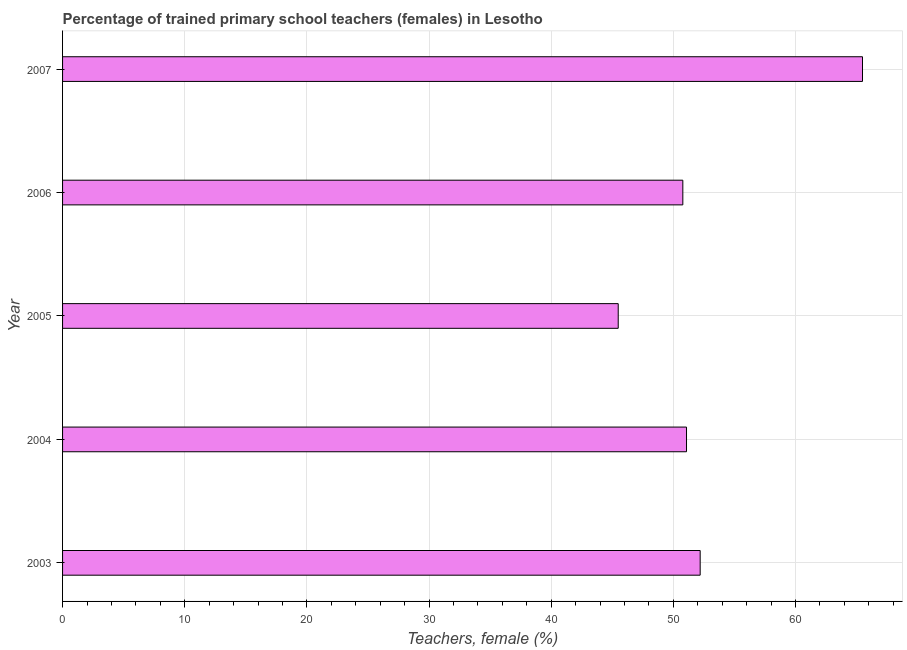Does the graph contain any zero values?
Keep it short and to the point. No. What is the title of the graph?
Your answer should be very brief. Percentage of trained primary school teachers (females) in Lesotho. What is the label or title of the X-axis?
Provide a short and direct response. Teachers, female (%). What is the percentage of trained female teachers in 2003?
Provide a short and direct response. 52.19. Across all years, what is the maximum percentage of trained female teachers?
Provide a succinct answer. 65.48. Across all years, what is the minimum percentage of trained female teachers?
Offer a terse response. 45.48. In which year was the percentage of trained female teachers minimum?
Ensure brevity in your answer.  2005. What is the sum of the percentage of trained female teachers?
Give a very brief answer. 265. What is the difference between the percentage of trained female teachers in 2003 and 2007?
Your answer should be very brief. -13.29. What is the median percentage of trained female teachers?
Provide a short and direct response. 51.07. What is the ratio of the percentage of trained female teachers in 2004 to that in 2007?
Provide a succinct answer. 0.78. Is the percentage of trained female teachers in 2004 less than that in 2007?
Give a very brief answer. Yes. Is the difference between the percentage of trained female teachers in 2003 and 2005 greater than the difference between any two years?
Offer a very short reply. No. What is the difference between the highest and the second highest percentage of trained female teachers?
Your response must be concise. 13.29. What is the difference between the highest and the lowest percentage of trained female teachers?
Keep it short and to the point. 20. Are all the bars in the graph horizontal?
Provide a succinct answer. Yes. How many years are there in the graph?
Make the answer very short. 5. What is the difference between two consecutive major ticks on the X-axis?
Give a very brief answer. 10. What is the Teachers, female (%) in 2003?
Your answer should be very brief. 52.19. What is the Teachers, female (%) in 2004?
Your answer should be very brief. 51.07. What is the Teachers, female (%) in 2005?
Keep it short and to the point. 45.48. What is the Teachers, female (%) of 2006?
Your answer should be very brief. 50.77. What is the Teachers, female (%) in 2007?
Your response must be concise. 65.48. What is the difference between the Teachers, female (%) in 2003 and 2004?
Provide a short and direct response. 1.12. What is the difference between the Teachers, female (%) in 2003 and 2005?
Offer a terse response. 6.71. What is the difference between the Teachers, female (%) in 2003 and 2006?
Your answer should be compact. 1.42. What is the difference between the Teachers, female (%) in 2003 and 2007?
Make the answer very short. -13.29. What is the difference between the Teachers, female (%) in 2004 and 2005?
Keep it short and to the point. 5.59. What is the difference between the Teachers, female (%) in 2004 and 2006?
Your answer should be compact. 0.3. What is the difference between the Teachers, female (%) in 2004 and 2007?
Your answer should be very brief. -14.41. What is the difference between the Teachers, female (%) in 2005 and 2006?
Offer a very short reply. -5.29. What is the difference between the Teachers, female (%) in 2005 and 2007?
Ensure brevity in your answer.  -20. What is the difference between the Teachers, female (%) in 2006 and 2007?
Ensure brevity in your answer.  -14.71. What is the ratio of the Teachers, female (%) in 2003 to that in 2005?
Make the answer very short. 1.15. What is the ratio of the Teachers, female (%) in 2003 to that in 2006?
Provide a short and direct response. 1.03. What is the ratio of the Teachers, female (%) in 2003 to that in 2007?
Ensure brevity in your answer.  0.8. What is the ratio of the Teachers, female (%) in 2004 to that in 2005?
Ensure brevity in your answer.  1.12. What is the ratio of the Teachers, female (%) in 2004 to that in 2007?
Keep it short and to the point. 0.78. What is the ratio of the Teachers, female (%) in 2005 to that in 2006?
Make the answer very short. 0.9. What is the ratio of the Teachers, female (%) in 2005 to that in 2007?
Provide a short and direct response. 0.69. What is the ratio of the Teachers, female (%) in 2006 to that in 2007?
Your answer should be compact. 0.78. 